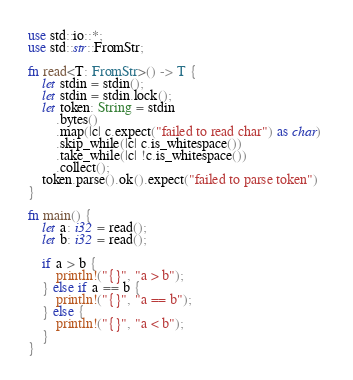Convert code to text. <code><loc_0><loc_0><loc_500><loc_500><_Rust_>use std::io::*;
use std::str::FromStr;

fn read<T: FromStr>() -> T {
    let stdin = stdin();
    let stdin = stdin.lock();
    let token: String = stdin
        .bytes()
        .map(|c| c.expect("failed to read char") as char) 
        .skip_while(|c| c.is_whitespace())
        .take_while(|c| !c.is_whitespace())
        .collect();
    token.parse().ok().expect("failed to parse token")
}

fn main() {
    let a: i32 = read();
    let b: i32 = read();
 
    if a > b {
        println!("{}", "a > b");
    } else if a == b {
        println!("{}", "a == b");
    } else {
        println!("{}", "a < b");
    }
}

</code> 